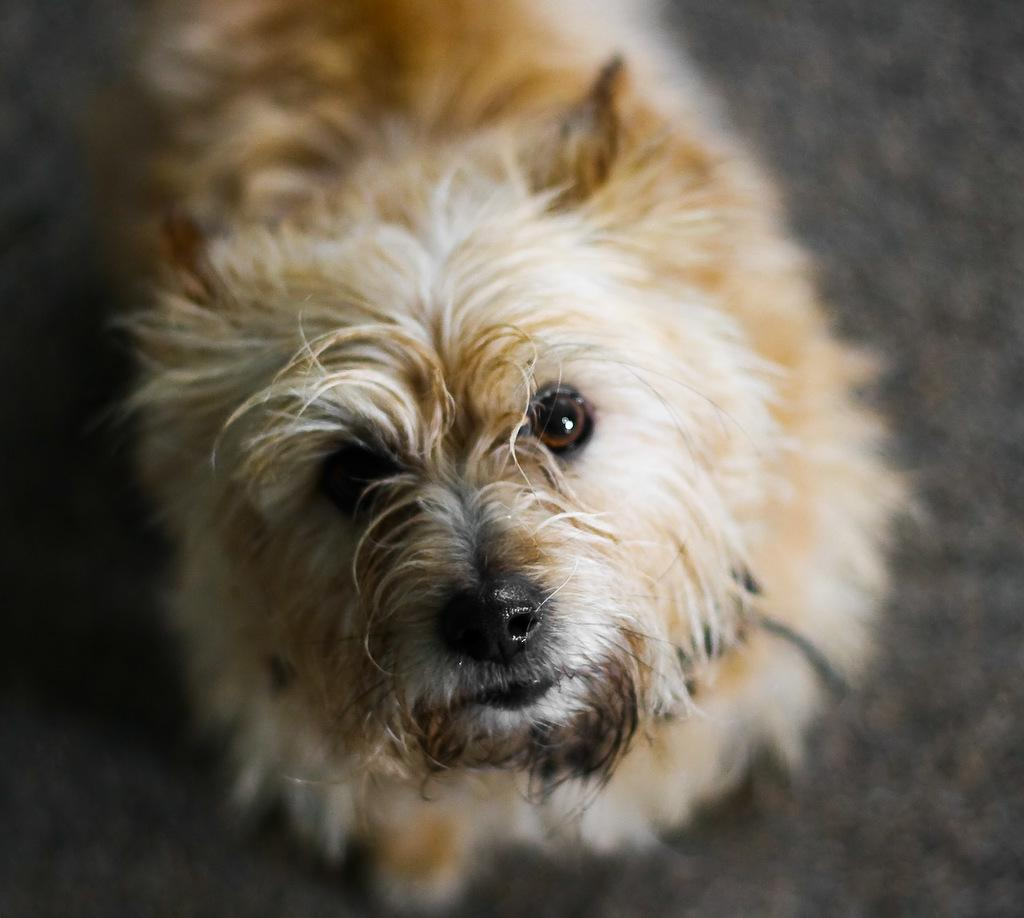What type of animal is present in the image? There is a dog in the image. Can you describe the dog's position in the image? The dog is standing on a path. What causes the dog to slip on the path in the image? There is no indication in the image that the dog is slipping on the path. What type of teeth does the dog have in the image? The image does not show the dog's teeth, so it cannot be determined from the picture. 